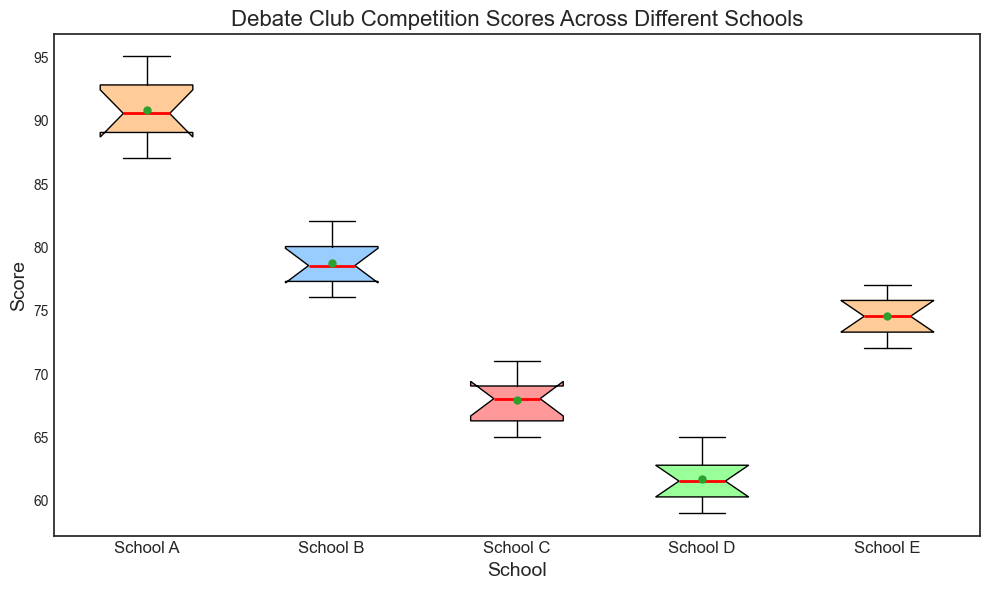What's the median score for School A? To determine the median score for School A, we need to arrange the scores in ascending order and find the middle value. The scores for School A, listed in ascending order, are: 87, 88, 89, 89, 90, 91, 92, 93, 94, 95. The median is the middle value, which is the average of the 5th and 6th scores: (90 + 91) / 2 = 90.5.
Answer: 90.5 Which school has the highest median score? To answer this, we compare the median scores of all schools. Based on the box plot, the school with the highest median score is School A, with a median score of 90.5.
Answer: School A What is the interquartile range (IQR) for School B? The interquartile range (IQR) is the difference between the 75th percentile (Q3) and the 25th percentile (Q1). For School B, let's determine these values from the box plot: Q3 is 80 and Q1 is 77. The IQR is Q3 - Q1 = 80 - 77 = 3.
Answer: 3 How does the spread of scores for School D compare to School E? To compare the spreads, we look at the width of the boxes in the box plot. The boxes represent the interquartile range (IQR). School D's box plot has a narrower IQR compared to School E, indicating that School D's scores are less spread out and more consistent.
Answer: School D has a narrower spread What's the mean score for School C, as shown in the plot? On the box plot, the mean score is indicated by a small circle. For School C, the mean score is visually marked around 67.
Answer: 67 Which school has the smallest range of scores? The range of scores is the difference between the maximum and minimum values. Visually, we can determine this by the length of the whiskers in the box plot. School D has the smallest range of scores, as indicated by the shortest whiskers.
Answer: School D Does any school have outliers in their scores? Outliers are typically presented as individual points outside the whiskers in a box plot. Based on the plot, there are no outliers indicated for any of the schools.
Answer: No What is the maximum score for School E? The maximum score for each school is represented by the topmost point of the whiskers. For School E, the maximum score, visually, is 77.
Answer: 77 Which school's box plot shows the most variation in scores? Variation in scores can be determined by the length of the box (IQR) and the length of whiskers. School A shows the most variation as it has the widest box plot, indicating a broad range of middle 50% scores.
Answer: School A 